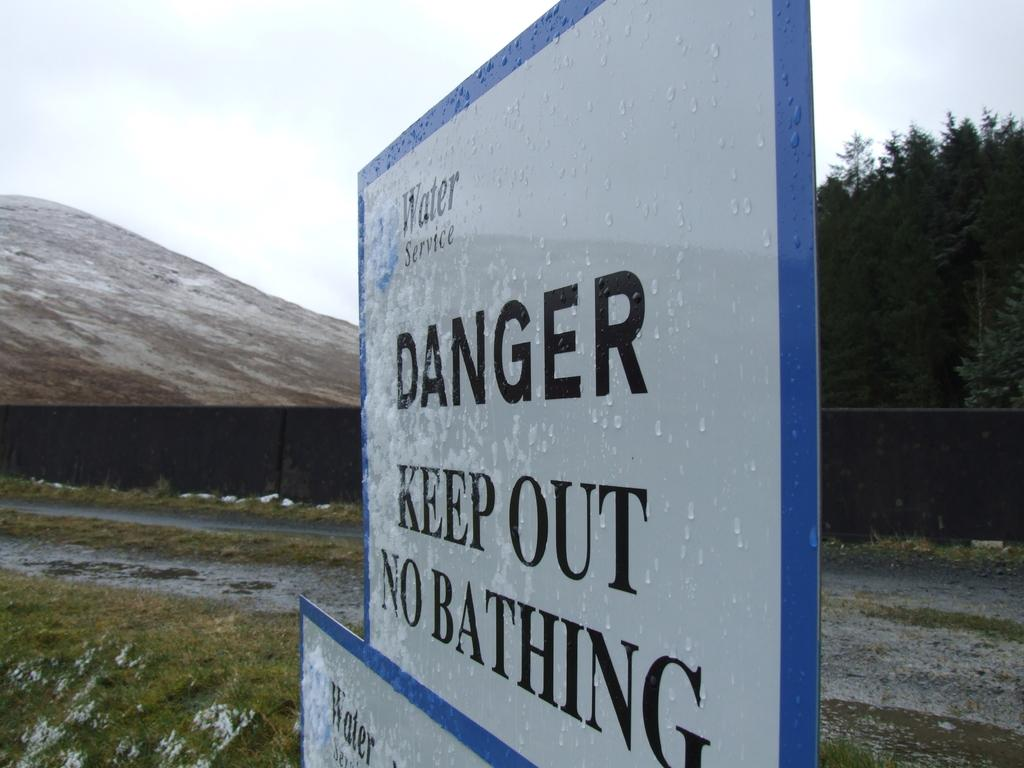What is the main object in the foreground of the image? There is a signboard with text in the foreground of the image. How is the signboard positioned in the image? The signboard is placed on the ground. What can be seen in the background of the image? There is a fence, a group of trees, a mountain, and the sky visible in the background of the image. What type of scent can be detected from the signboard in the image? There is no indication of a scent associated with the signboard in the image. 